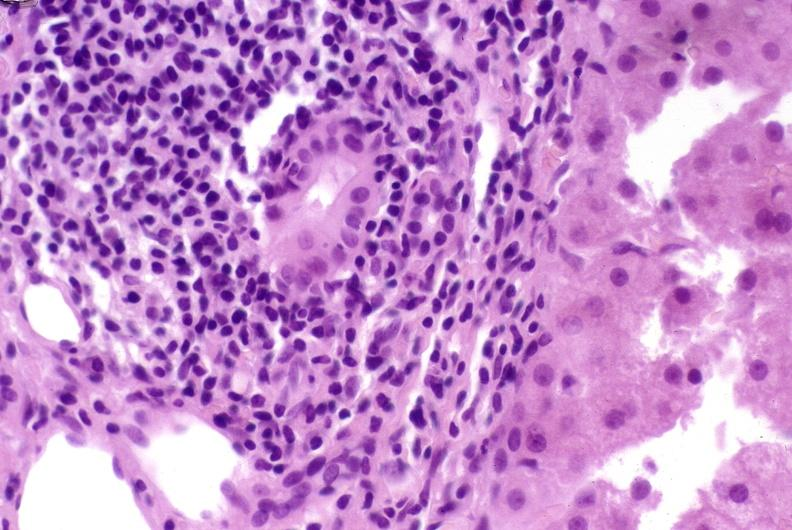what is present?
Answer the question using a single word or phrase. Hepatobiliary 